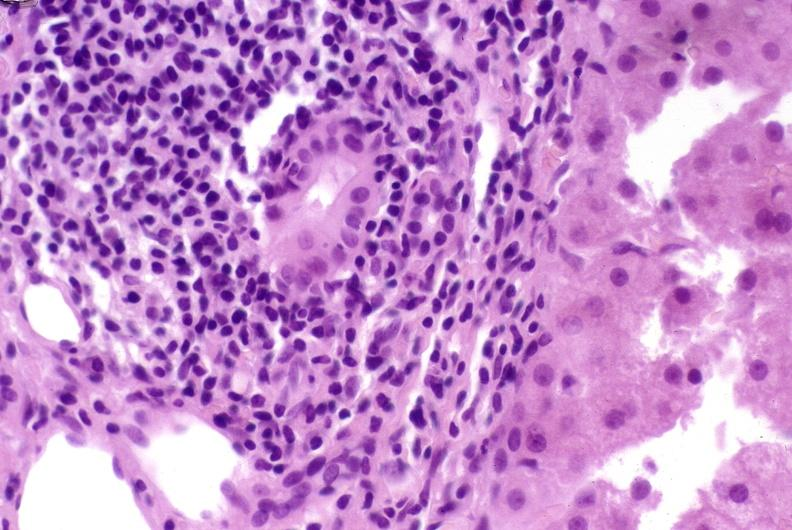what is present?
Answer the question using a single word or phrase. Hepatobiliary 